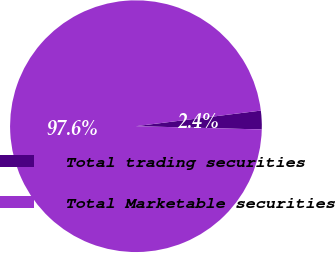Convert chart to OTSL. <chart><loc_0><loc_0><loc_500><loc_500><pie_chart><fcel>Total trading securities<fcel>Total Marketable securities<nl><fcel>2.39%<fcel>97.61%<nl></chart> 